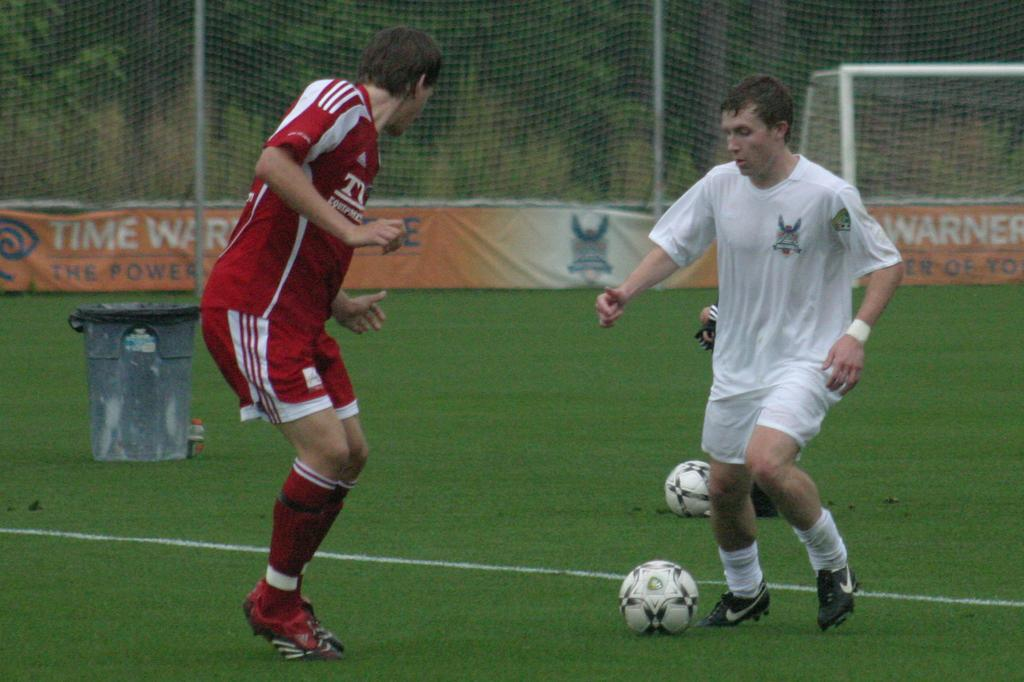<image>
Describe the image concisely. Soccer player wearing a red jersey with the letter T on it. 